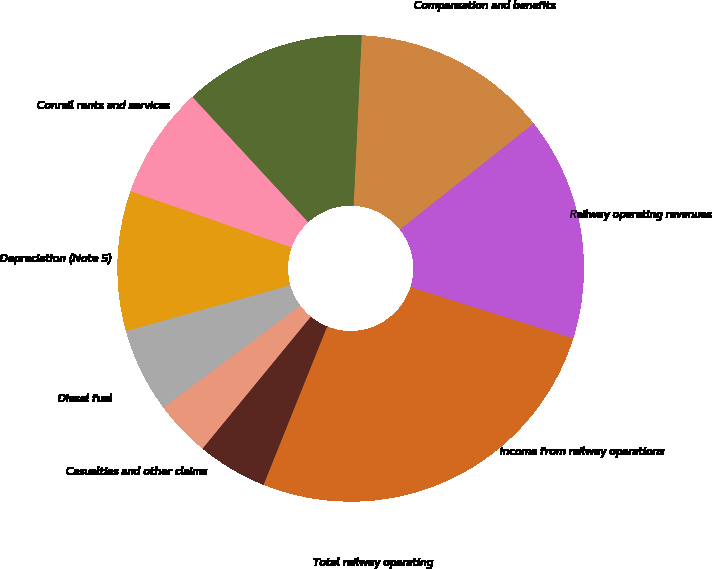Convert chart. <chart><loc_0><loc_0><loc_500><loc_500><pie_chart><fcel>Railway operating revenues<fcel>Compensation and benefits<fcel>Materials services and rents<fcel>Conrail rents and services<fcel>Depreciation (Note 5)<fcel>Diesel fuel<fcel>Casualties and other claims<fcel>Other<fcel>Total railway operating<fcel>Income from railway operations<nl><fcel>15.53%<fcel>13.59%<fcel>12.62%<fcel>7.77%<fcel>9.71%<fcel>5.83%<fcel>3.88%<fcel>4.86%<fcel>14.56%<fcel>11.65%<nl></chart> 